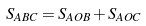Convert formula to latex. <formula><loc_0><loc_0><loc_500><loc_500>S _ { A B C } = S _ { A O B } + S _ { A O C }</formula> 